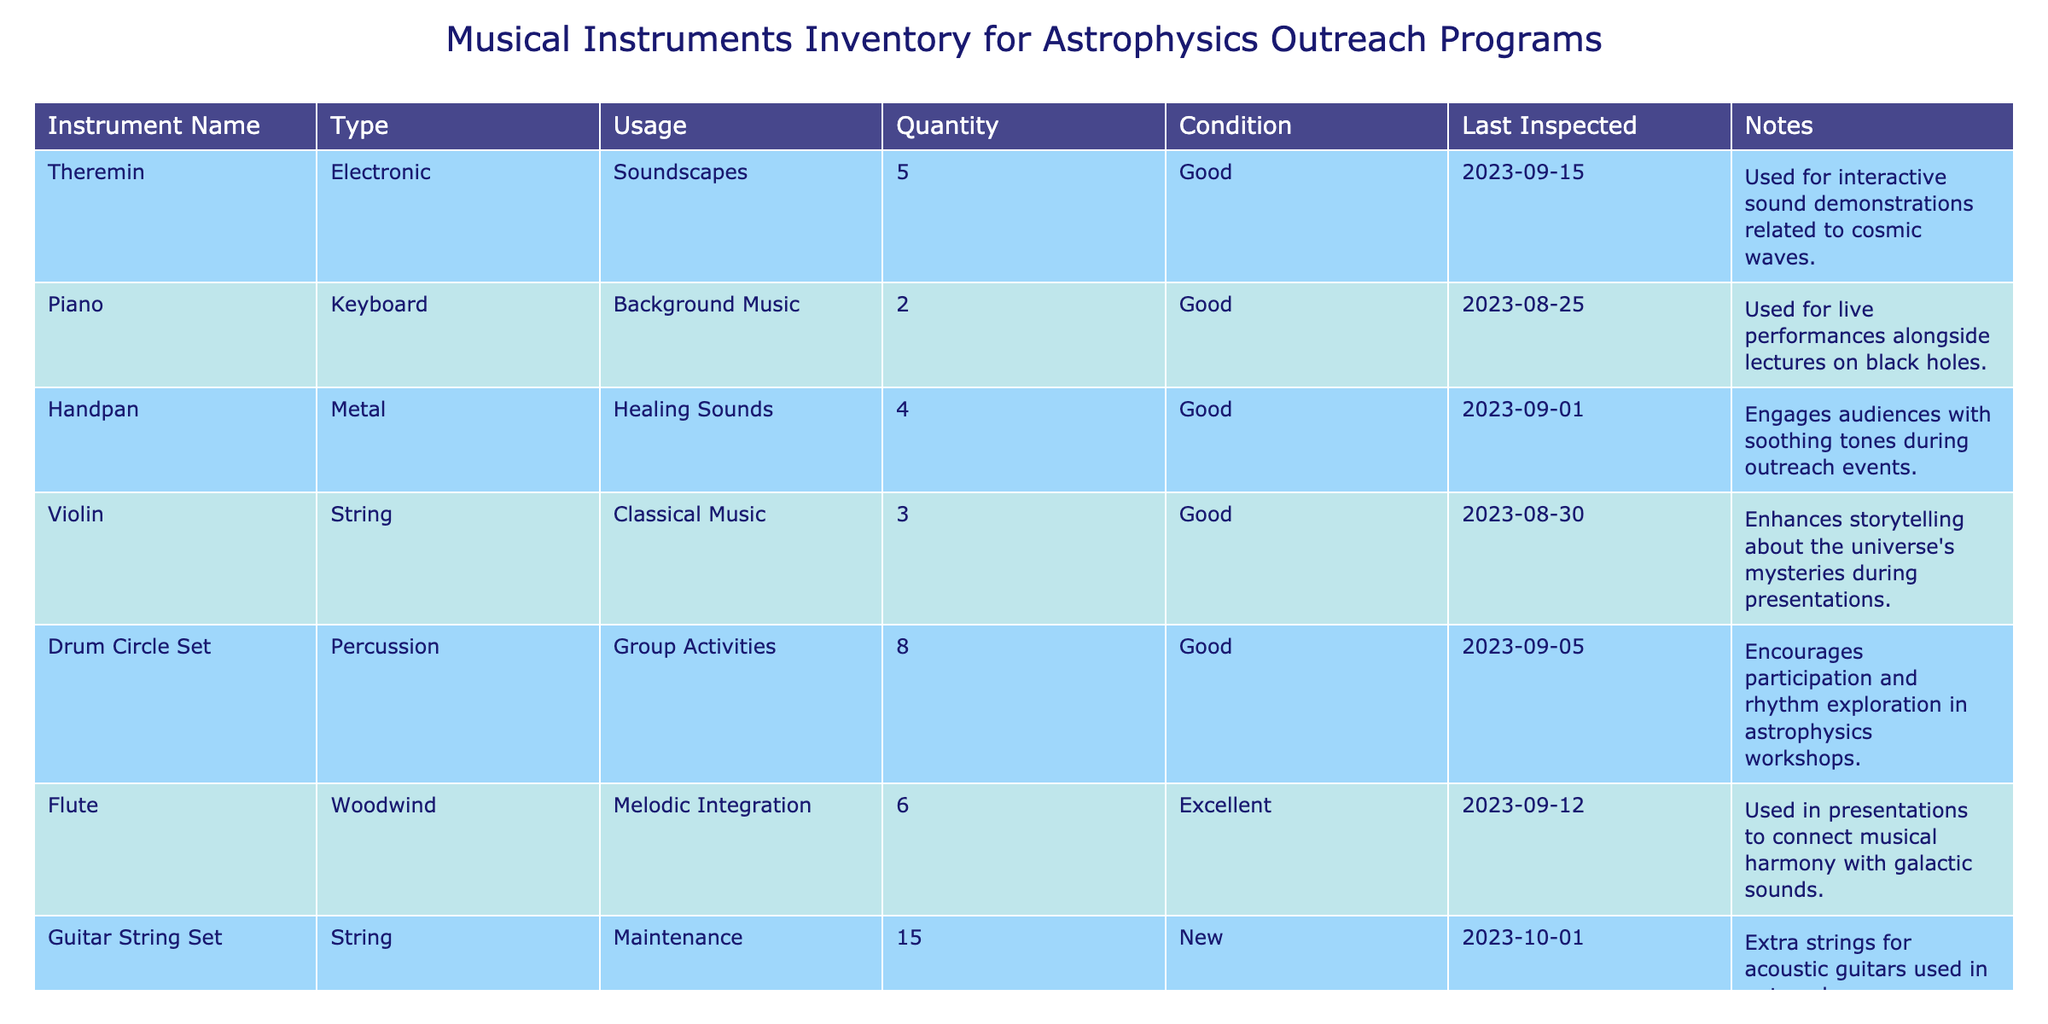What is the total quantity of electronic instruments? The table lists two electronic instruments: Theremin (5) and Synthesizer (3). We sum their quantities: 5 + 3 = 8.
Answer: 8 How many instruments are in excellent condition? The table shows only one instrument in excellent condition: Flute (6). Therefore, the total is just 6.
Answer: 6 Is the Handpan used for healing sounds? The notes for Handpan confirm it is used for healing sounds, so this statement is true.
Answer: Yes What is the combined quantity of string instruments? The string instruments are Violin (3), Guitar String Set (15), and the quantity of Guitar String Set is not counted as an instrument used in the performance, so we consider only Violin. Thus, the combined quantity is 3.
Answer: 3 Which instrument has the most units available, and how many are there? The instrument with the most units is Drum Circle Set, with 8 units. We can read the value directly from the table.
Answer: Drum Circle Set, 8 How many instruments are used for interactive experiences? The instruments used for interactive experiences are Theremin (5), Drum Circle Set (8), and Marimba (2). We add them up: 5 + 8 + 2 = 15.
Answer: 15 Was the last inspection date for the Piano more recent than for the Violin? The last inspection date for Piano is 2023-08-25 and for Violin is 2023-08-30. Since Violin's inspection date is later, the statement is false.
Answer: No What type of usage is associated with the Flute? The usage associated with the Flute in the table is "Melodic Integration," indicating its purpose in outreach programs.
Answer: Melodic Integration Which instrument is used to connect musical harmony with galactic sounds? The Flute is specified in the notes for its usage to connect musical harmony with galactic sounds.
Answer: Flute 